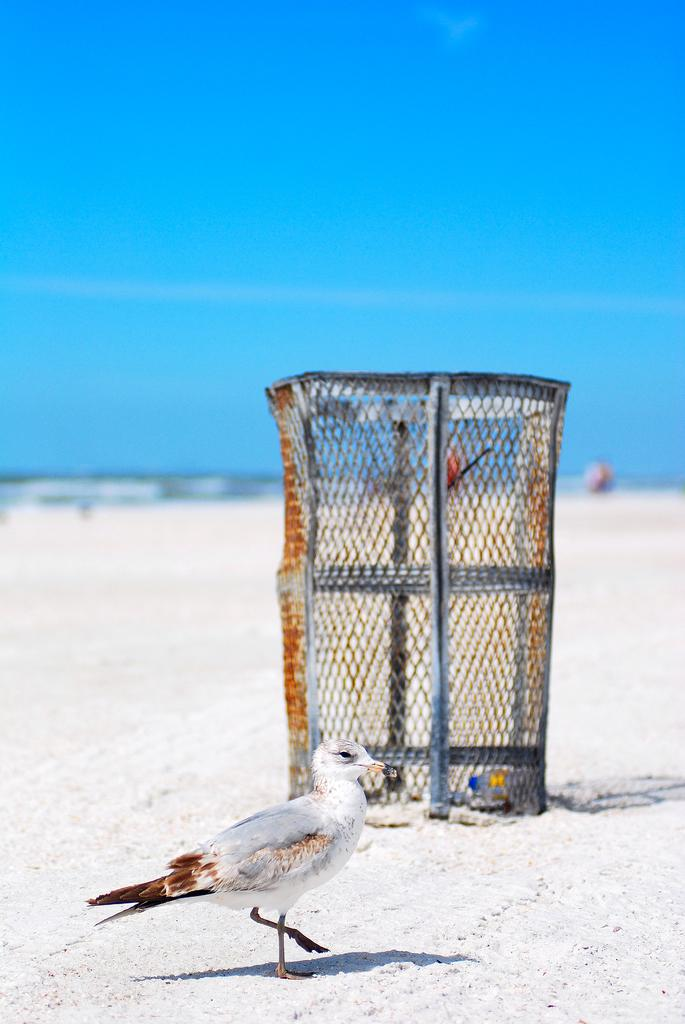What type of animal is present in the image? There is a bird in the image. What is located near the bird in the image? There is a cage near the bird in the image. What can be seen in the background of the image? The sky is visible in the background of the image. What type of fact can be seen in the image? There is no fact present in the image; it features a bird and a cage. What type of lace can be seen on the bird in the image? There is no lace present on the bird in the image. How many boats are visible in the image? There are no boats visible in the image. 